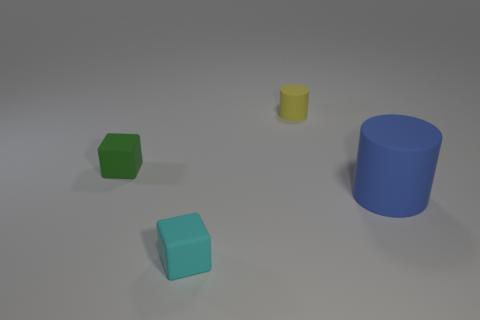Subtract all yellow cylinders. How many cylinders are left? 1 Add 3 matte cylinders. How many matte cylinders exist? 5 Add 4 matte objects. How many objects exist? 8 Subtract 0 cyan balls. How many objects are left? 4 Subtract 2 cubes. How many cubes are left? 0 Subtract all blue cylinders. Subtract all cyan cubes. How many cylinders are left? 1 Subtract all green cubes. How many blue cylinders are left? 1 Subtract all small yellow rubber things. Subtract all blue rubber cylinders. How many objects are left? 2 Add 2 tiny yellow matte objects. How many tiny yellow matte objects are left? 3 